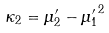Convert formula to latex. <formula><loc_0><loc_0><loc_500><loc_500>\kappa _ { 2 } = \mu _ { 2 } ^ { \prime } - { \mu _ { 1 } ^ { \prime } } ^ { 2 }</formula> 